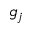Convert formula to latex. <formula><loc_0><loc_0><loc_500><loc_500>g _ { j }</formula> 